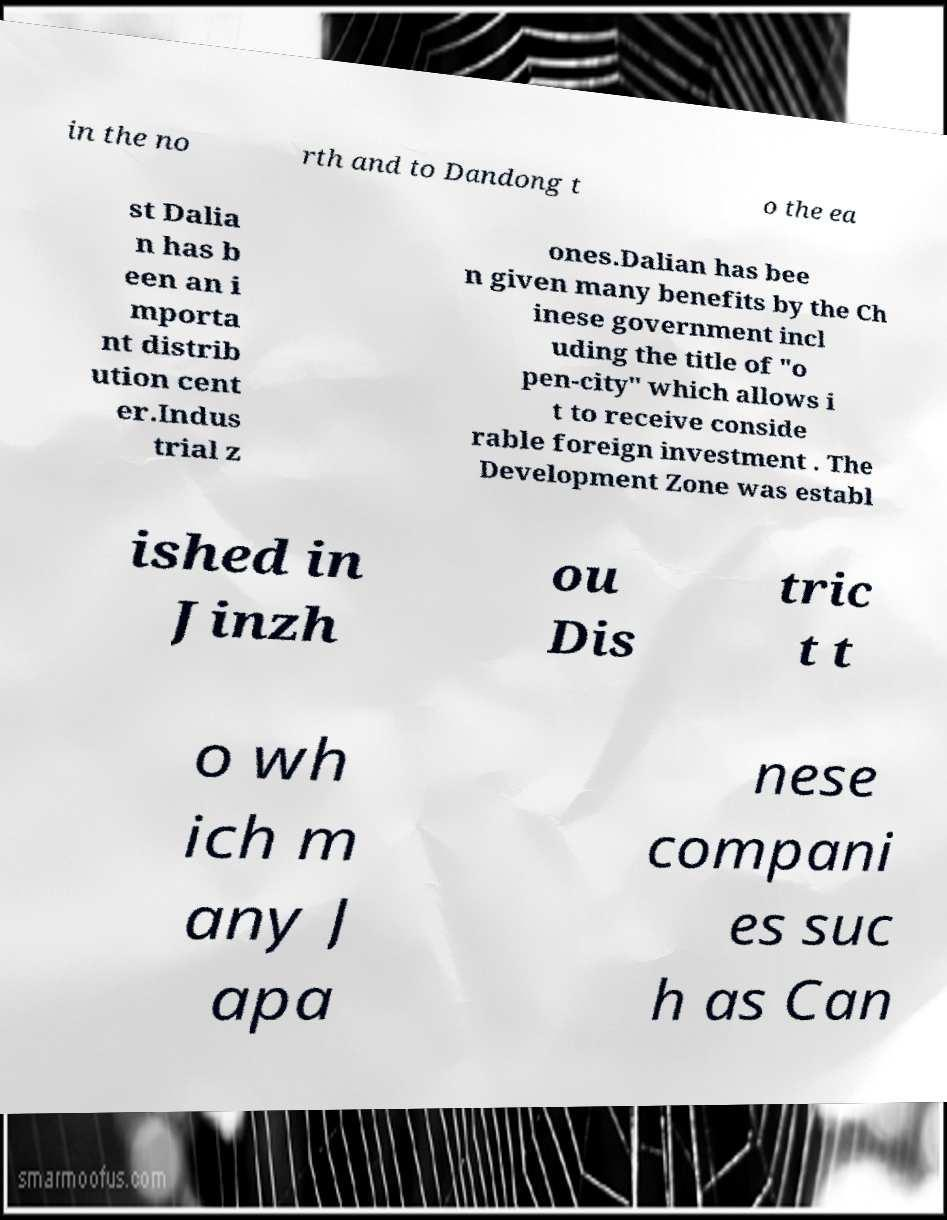There's text embedded in this image that I need extracted. Can you transcribe it verbatim? in the no rth and to Dandong t o the ea st Dalia n has b een an i mporta nt distrib ution cent er.Indus trial z ones.Dalian has bee n given many benefits by the Ch inese government incl uding the title of "o pen-city" which allows i t to receive conside rable foreign investment . The Development Zone was establ ished in Jinzh ou Dis tric t t o wh ich m any J apa nese compani es suc h as Can 